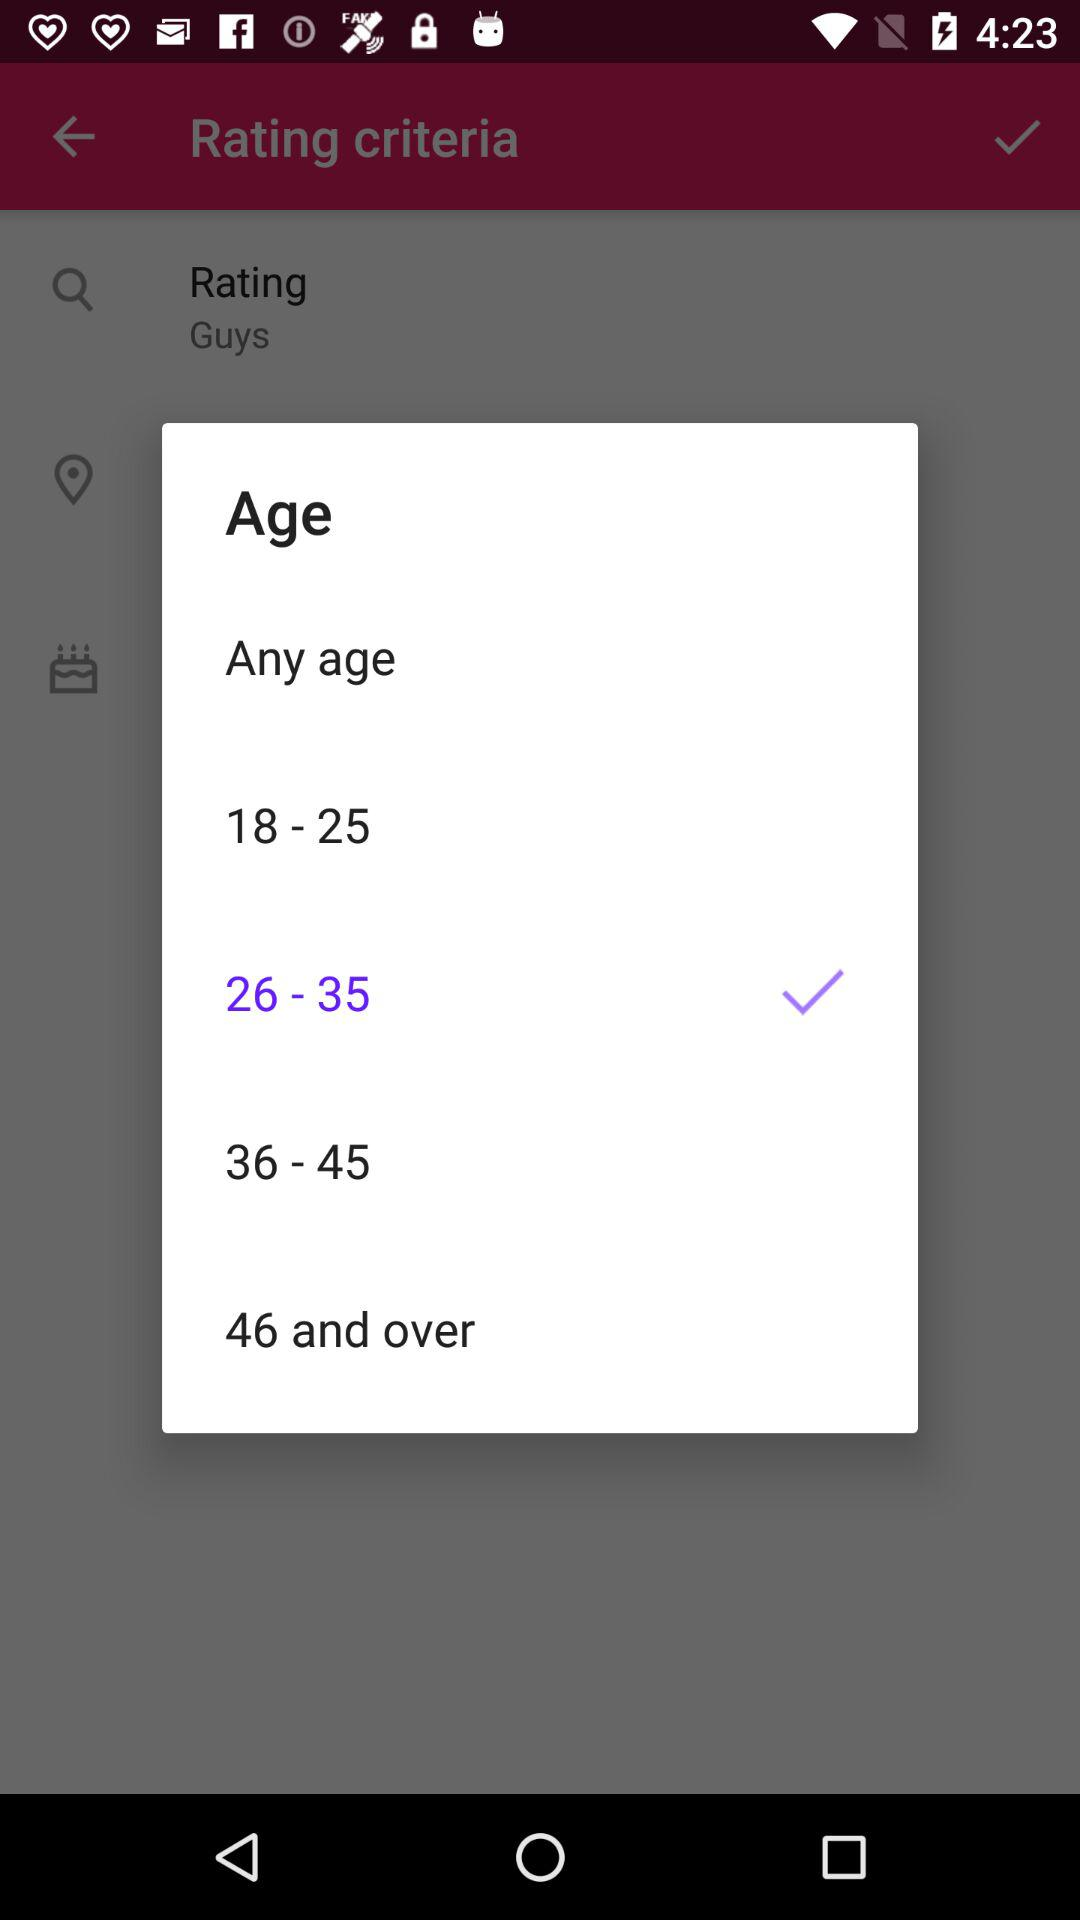Is 18-25 range selected?
When the provided information is insufficient, respond with <no answer>. <no answer> 